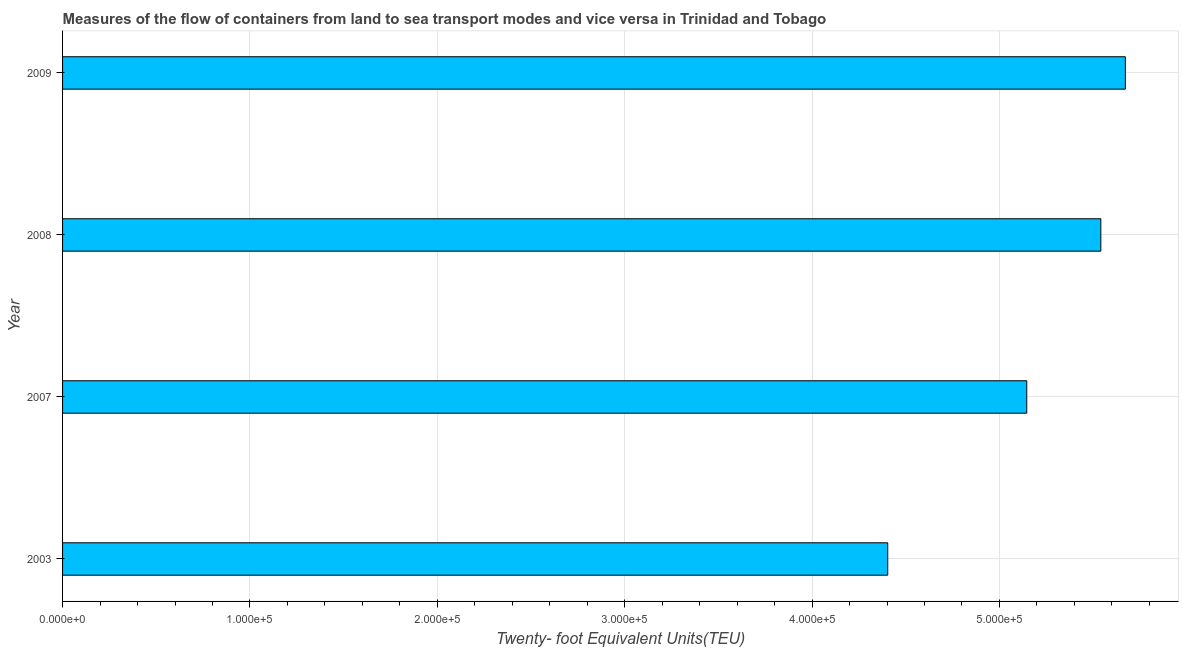Does the graph contain grids?
Give a very brief answer. Yes. What is the title of the graph?
Provide a succinct answer. Measures of the flow of containers from land to sea transport modes and vice versa in Trinidad and Tobago. What is the label or title of the X-axis?
Give a very brief answer. Twenty- foot Equivalent Units(TEU). What is the label or title of the Y-axis?
Your answer should be compact. Year. What is the container port traffic in 2007?
Make the answer very short. 5.15e+05. Across all years, what is the maximum container port traffic?
Give a very brief answer. 5.67e+05. Across all years, what is the minimum container port traffic?
Ensure brevity in your answer.  4.40e+05. What is the sum of the container port traffic?
Your answer should be very brief. 2.08e+06. What is the difference between the container port traffic in 2003 and 2009?
Keep it short and to the point. -1.27e+05. What is the average container port traffic per year?
Offer a very short reply. 5.19e+05. What is the median container port traffic?
Offer a terse response. 5.34e+05. In how many years, is the container port traffic greater than 400000 TEU?
Offer a very short reply. 4. What is the ratio of the container port traffic in 2003 to that in 2007?
Make the answer very short. 0.86. Is the difference between the container port traffic in 2008 and 2009 greater than the difference between any two years?
Offer a very short reply. No. What is the difference between the highest and the second highest container port traffic?
Your answer should be compact. 1.31e+04. Is the sum of the container port traffic in 2007 and 2008 greater than the maximum container port traffic across all years?
Your answer should be very brief. Yes. What is the difference between the highest and the lowest container port traffic?
Your answer should be compact. 1.27e+05. Are all the bars in the graph horizontal?
Your answer should be compact. Yes. What is the difference between two consecutive major ticks on the X-axis?
Your answer should be very brief. 1.00e+05. What is the Twenty- foot Equivalent Units(TEU) of 2003?
Your response must be concise. 4.40e+05. What is the Twenty- foot Equivalent Units(TEU) of 2007?
Your answer should be compact. 5.15e+05. What is the Twenty- foot Equivalent Units(TEU) of 2008?
Make the answer very short. 5.54e+05. What is the Twenty- foot Equivalent Units(TEU) of 2009?
Give a very brief answer. 5.67e+05. What is the difference between the Twenty- foot Equivalent Units(TEU) in 2003 and 2007?
Offer a very short reply. -7.42e+04. What is the difference between the Twenty- foot Equivalent Units(TEU) in 2003 and 2008?
Make the answer very short. -1.14e+05. What is the difference between the Twenty- foot Equivalent Units(TEU) in 2003 and 2009?
Make the answer very short. -1.27e+05. What is the difference between the Twenty- foot Equivalent Units(TEU) in 2007 and 2008?
Keep it short and to the point. -3.95e+04. What is the difference between the Twenty- foot Equivalent Units(TEU) in 2007 and 2009?
Your answer should be very brief. -5.26e+04. What is the difference between the Twenty- foot Equivalent Units(TEU) in 2008 and 2009?
Provide a short and direct response. -1.31e+04. What is the ratio of the Twenty- foot Equivalent Units(TEU) in 2003 to that in 2007?
Provide a succinct answer. 0.86. What is the ratio of the Twenty- foot Equivalent Units(TEU) in 2003 to that in 2008?
Provide a short and direct response. 0.8. What is the ratio of the Twenty- foot Equivalent Units(TEU) in 2003 to that in 2009?
Ensure brevity in your answer.  0.78. What is the ratio of the Twenty- foot Equivalent Units(TEU) in 2007 to that in 2008?
Your answer should be very brief. 0.93. What is the ratio of the Twenty- foot Equivalent Units(TEU) in 2007 to that in 2009?
Make the answer very short. 0.91. 